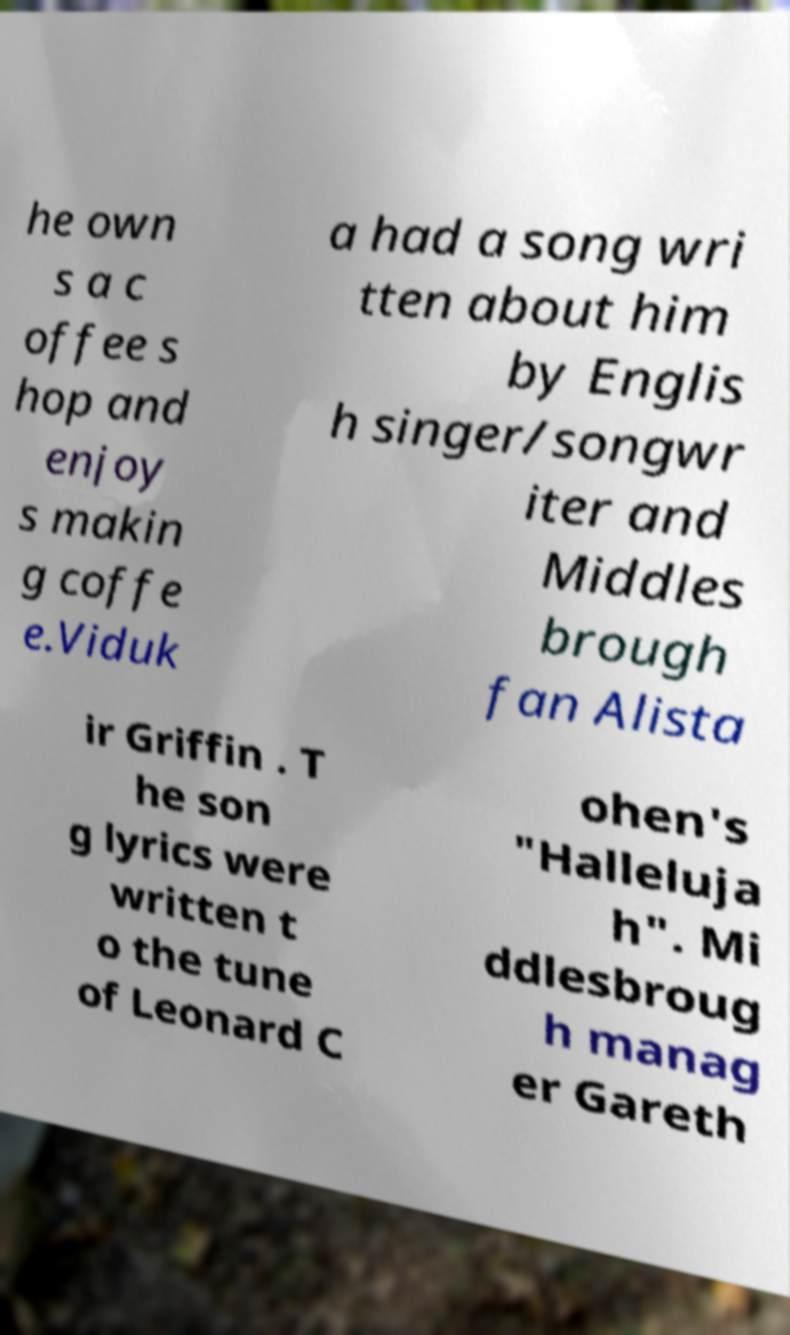Could you extract and type out the text from this image? he own s a c offee s hop and enjoy s makin g coffe e.Viduk a had a song wri tten about him by Englis h singer/songwr iter and Middles brough fan Alista ir Griffin . T he son g lyrics were written t o the tune of Leonard C ohen's "Halleluja h". Mi ddlesbroug h manag er Gareth 